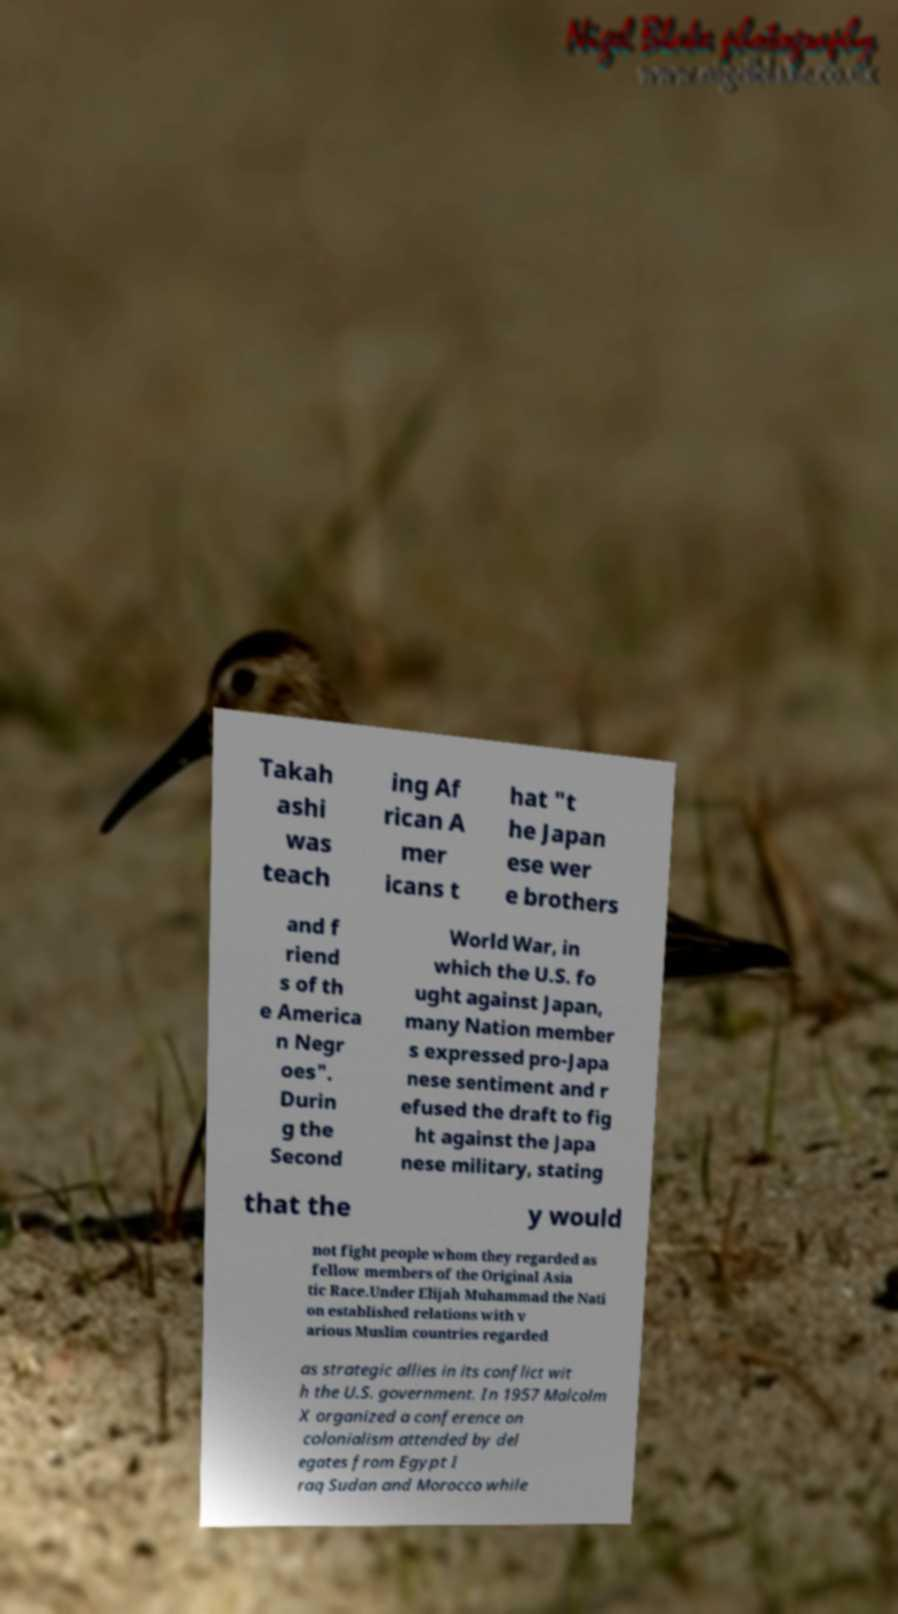I need the written content from this picture converted into text. Can you do that? Takah ashi was teach ing Af rican A mer icans t hat "t he Japan ese wer e brothers and f riend s of th e America n Negr oes". Durin g the Second World War, in which the U.S. fo ught against Japan, many Nation member s expressed pro-Japa nese sentiment and r efused the draft to fig ht against the Japa nese military, stating that the y would not fight people whom they regarded as fellow members of the Original Asia tic Race.Under Elijah Muhammad the Nati on established relations with v arious Muslim countries regarded as strategic allies in its conflict wit h the U.S. government. In 1957 Malcolm X organized a conference on colonialism attended by del egates from Egypt I raq Sudan and Morocco while 